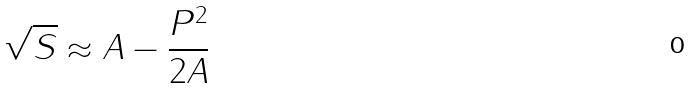<formula> <loc_0><loc_0><loc_500><loc_500>\sqrt { S } \approx A - \frac { P ^ { 2 } } { 2 A }</formula> 